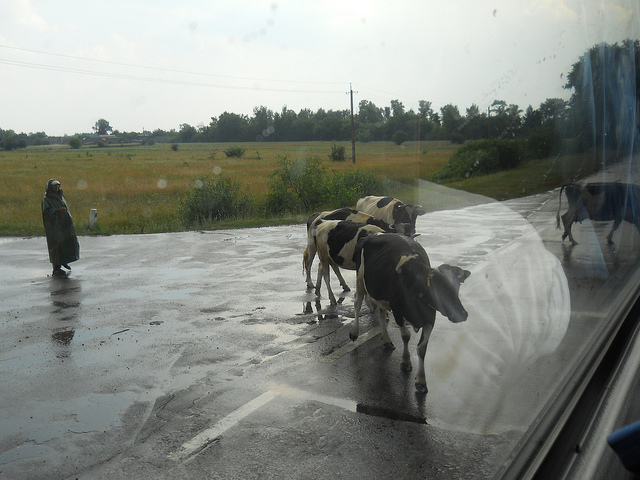What is the person in the background doing? The person is standing at the side of the road, seemingly watching the cows pass by. The figure appears to be dressed in a long garment, which might indicate cultural or regional clothing. 